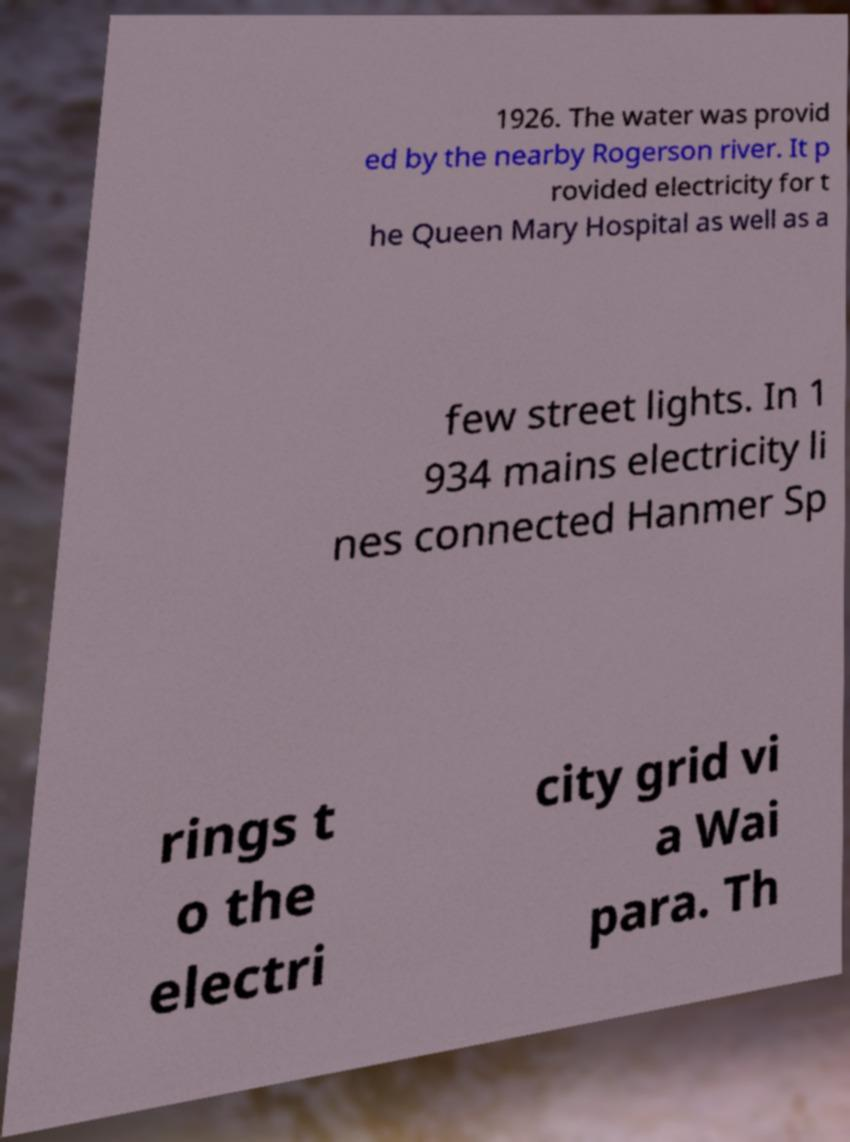Can you read and provide the text displayed in the image?This photo seems to have some interesting text. Can you extract and type it out for me? 1926. The water was provid ed by the nearby Rogerson river. It p rovided electricity for t he Queen Mary Hospital as well as a few street lights. In 1 934 mains electricity li nes connected Hanmer Sp rings t o the electri city grid vi a Wai para. Th 